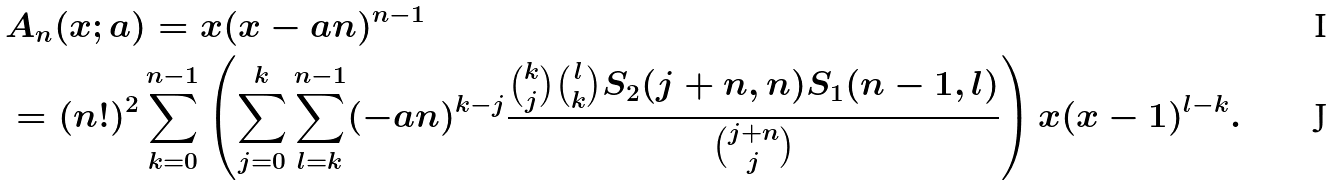Convert formula to latex. <formula><loc_0><loc_0><loc_500><loc_500>& A _ { n } ( x ; a ) = x ( x - a n ) ^ { n - 1 } \\ & = ( n ! ) ^ { 2 } \sum _ { k = 0 } ^ { n - 1 } \left ( \sum _ { j = 0 } ^ { k } \sum _ { l = k } ^ { n - 1 } ( - a n ) ^ { k - j } \frac { \binom { k } { j } \binom { l } { k } S _ { 2 } ( j + n , n ) S _ { 1 } ( n - 1 , l ) } { \binom { j + n } { j } } \right ) x ( x - 1 ) ^ { l - k } .</formula> 